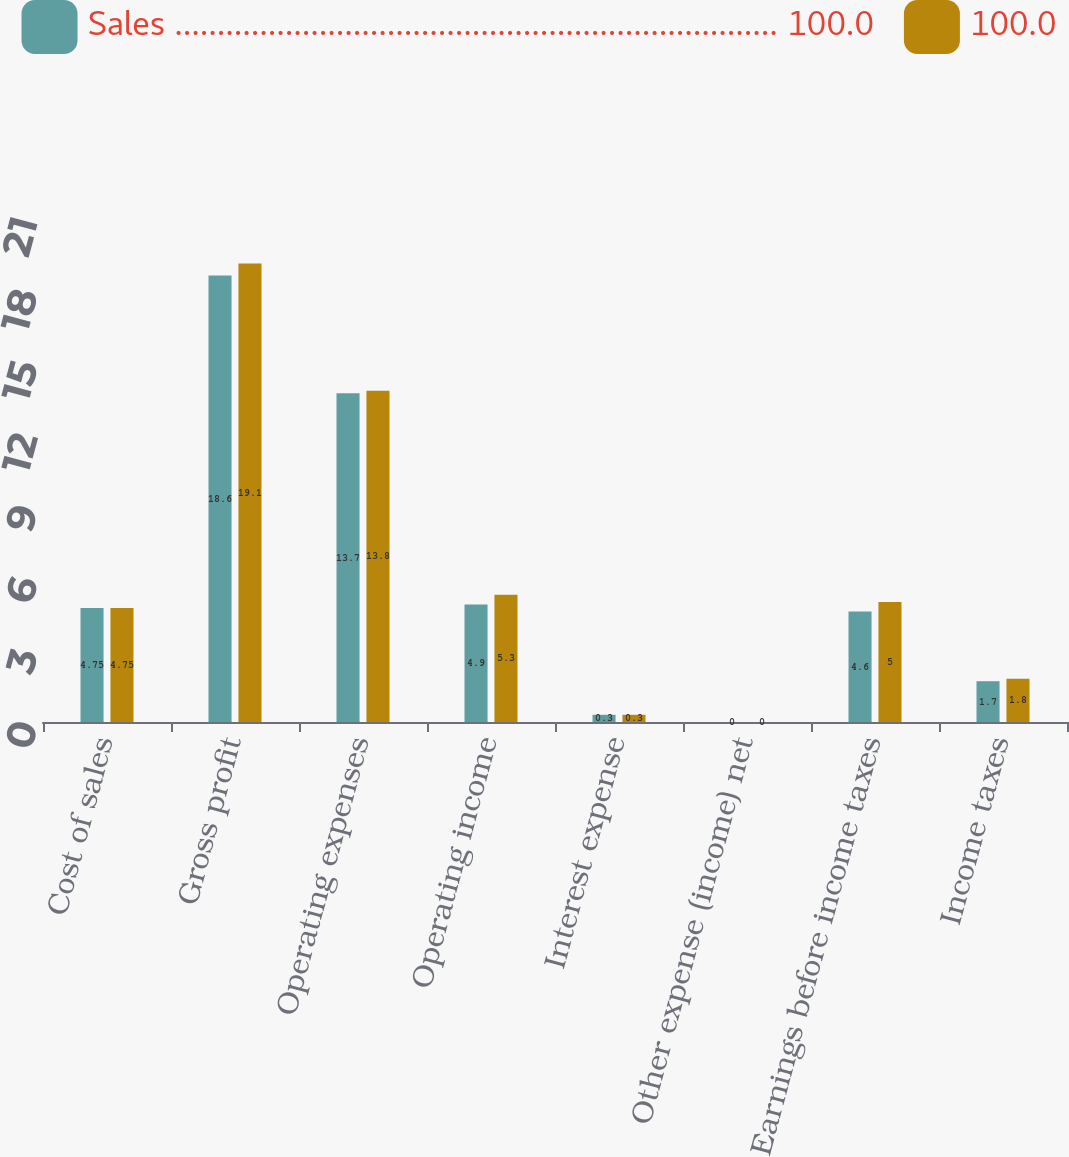Convert chart. <chart><loc_0><loc_0><loc_500><loc_500><stacked_bar_chart><ecel><fcel>Cost of sales<fcel>Gross profit<fcel>Operating expenses<fcel>Operating income<fcel>Interest expense<fcel>Other expense (income) net<fcel>Earnings before income taxes<fcel>Income taxes<nl><fcel>Sales ....................................................................... 100.0<fcel>4.75<fcel>18.6<fcel>13.7<fcel>4.9<fcel>0.3<fcel>0<fcel>4.6<fcel>1.7<nl><fcel>100.0<fcel>4.75<fcel>19.1<fcel>13.8<fcel>5.3<fcel>0.3<fcel>0<fcel>5<fcel>1.8<nl></chart> 